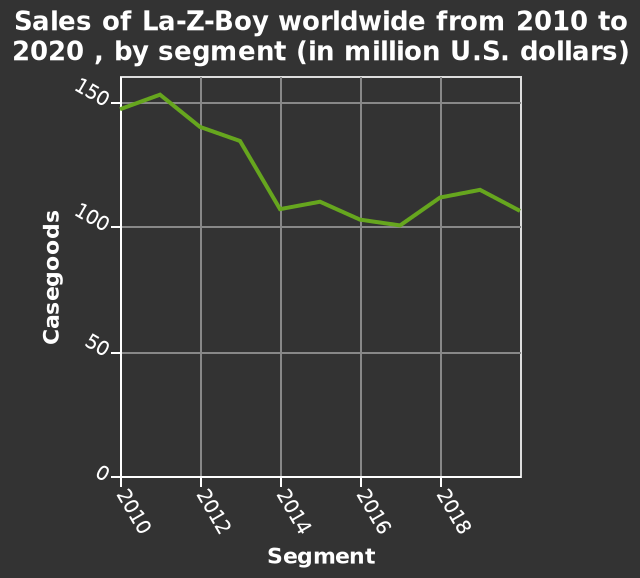<image>
What does the y-axis represent in the line graph?  The y-axis represents the sales of Casegoods. Was there an increase in casegoods from 2017 to 2019?  Yes, there were increases in casegoods from the year 2017 to 2019. 